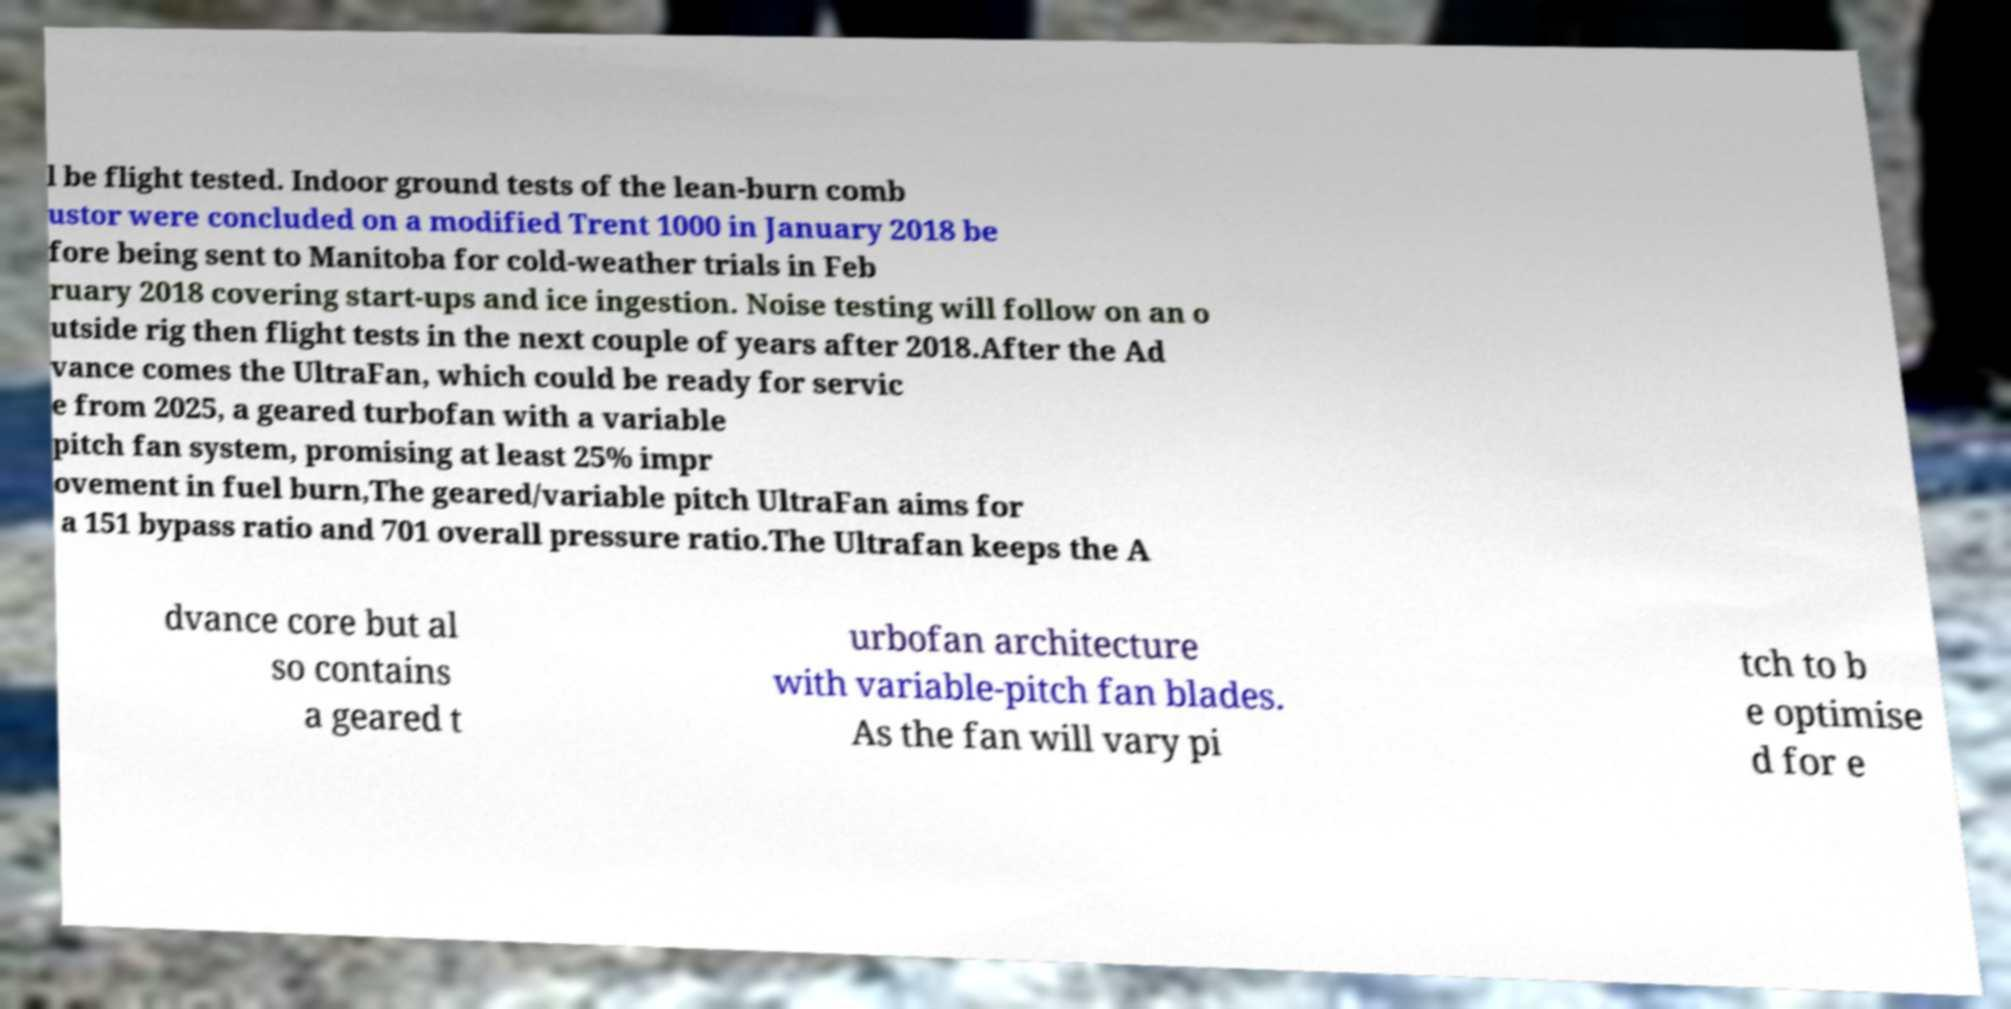Can you accurately transcribe the text from the provided image for me? l be flight tested. Indoor ground tests of the lean-burn comb ustor were concluded on a modified Trent 1000 in January 2018 be fore being sent to Manitoba for cold-weather trials in Feb ruary 2018 covering start-ups and ice ingestion. Noise testing will follow on an o utside rig then flight tests in the next couple of years after 2018.After the Ad vance comes the UltraFan, which could be ready for servic e from 2025, a geared turbofan with a variable pitch fan system, promising at least 25% impr ovement in fuel burn,The geared/variable pitch UltraFan aims for a 151 bypass ratio and 701 overall pressure ratio.The Ultrafan keeps the A dvance core but al so contains a geared t urbofan architecture with variable-pitch fan blades. As the fan will vary pi tch to b e optimise d for e 